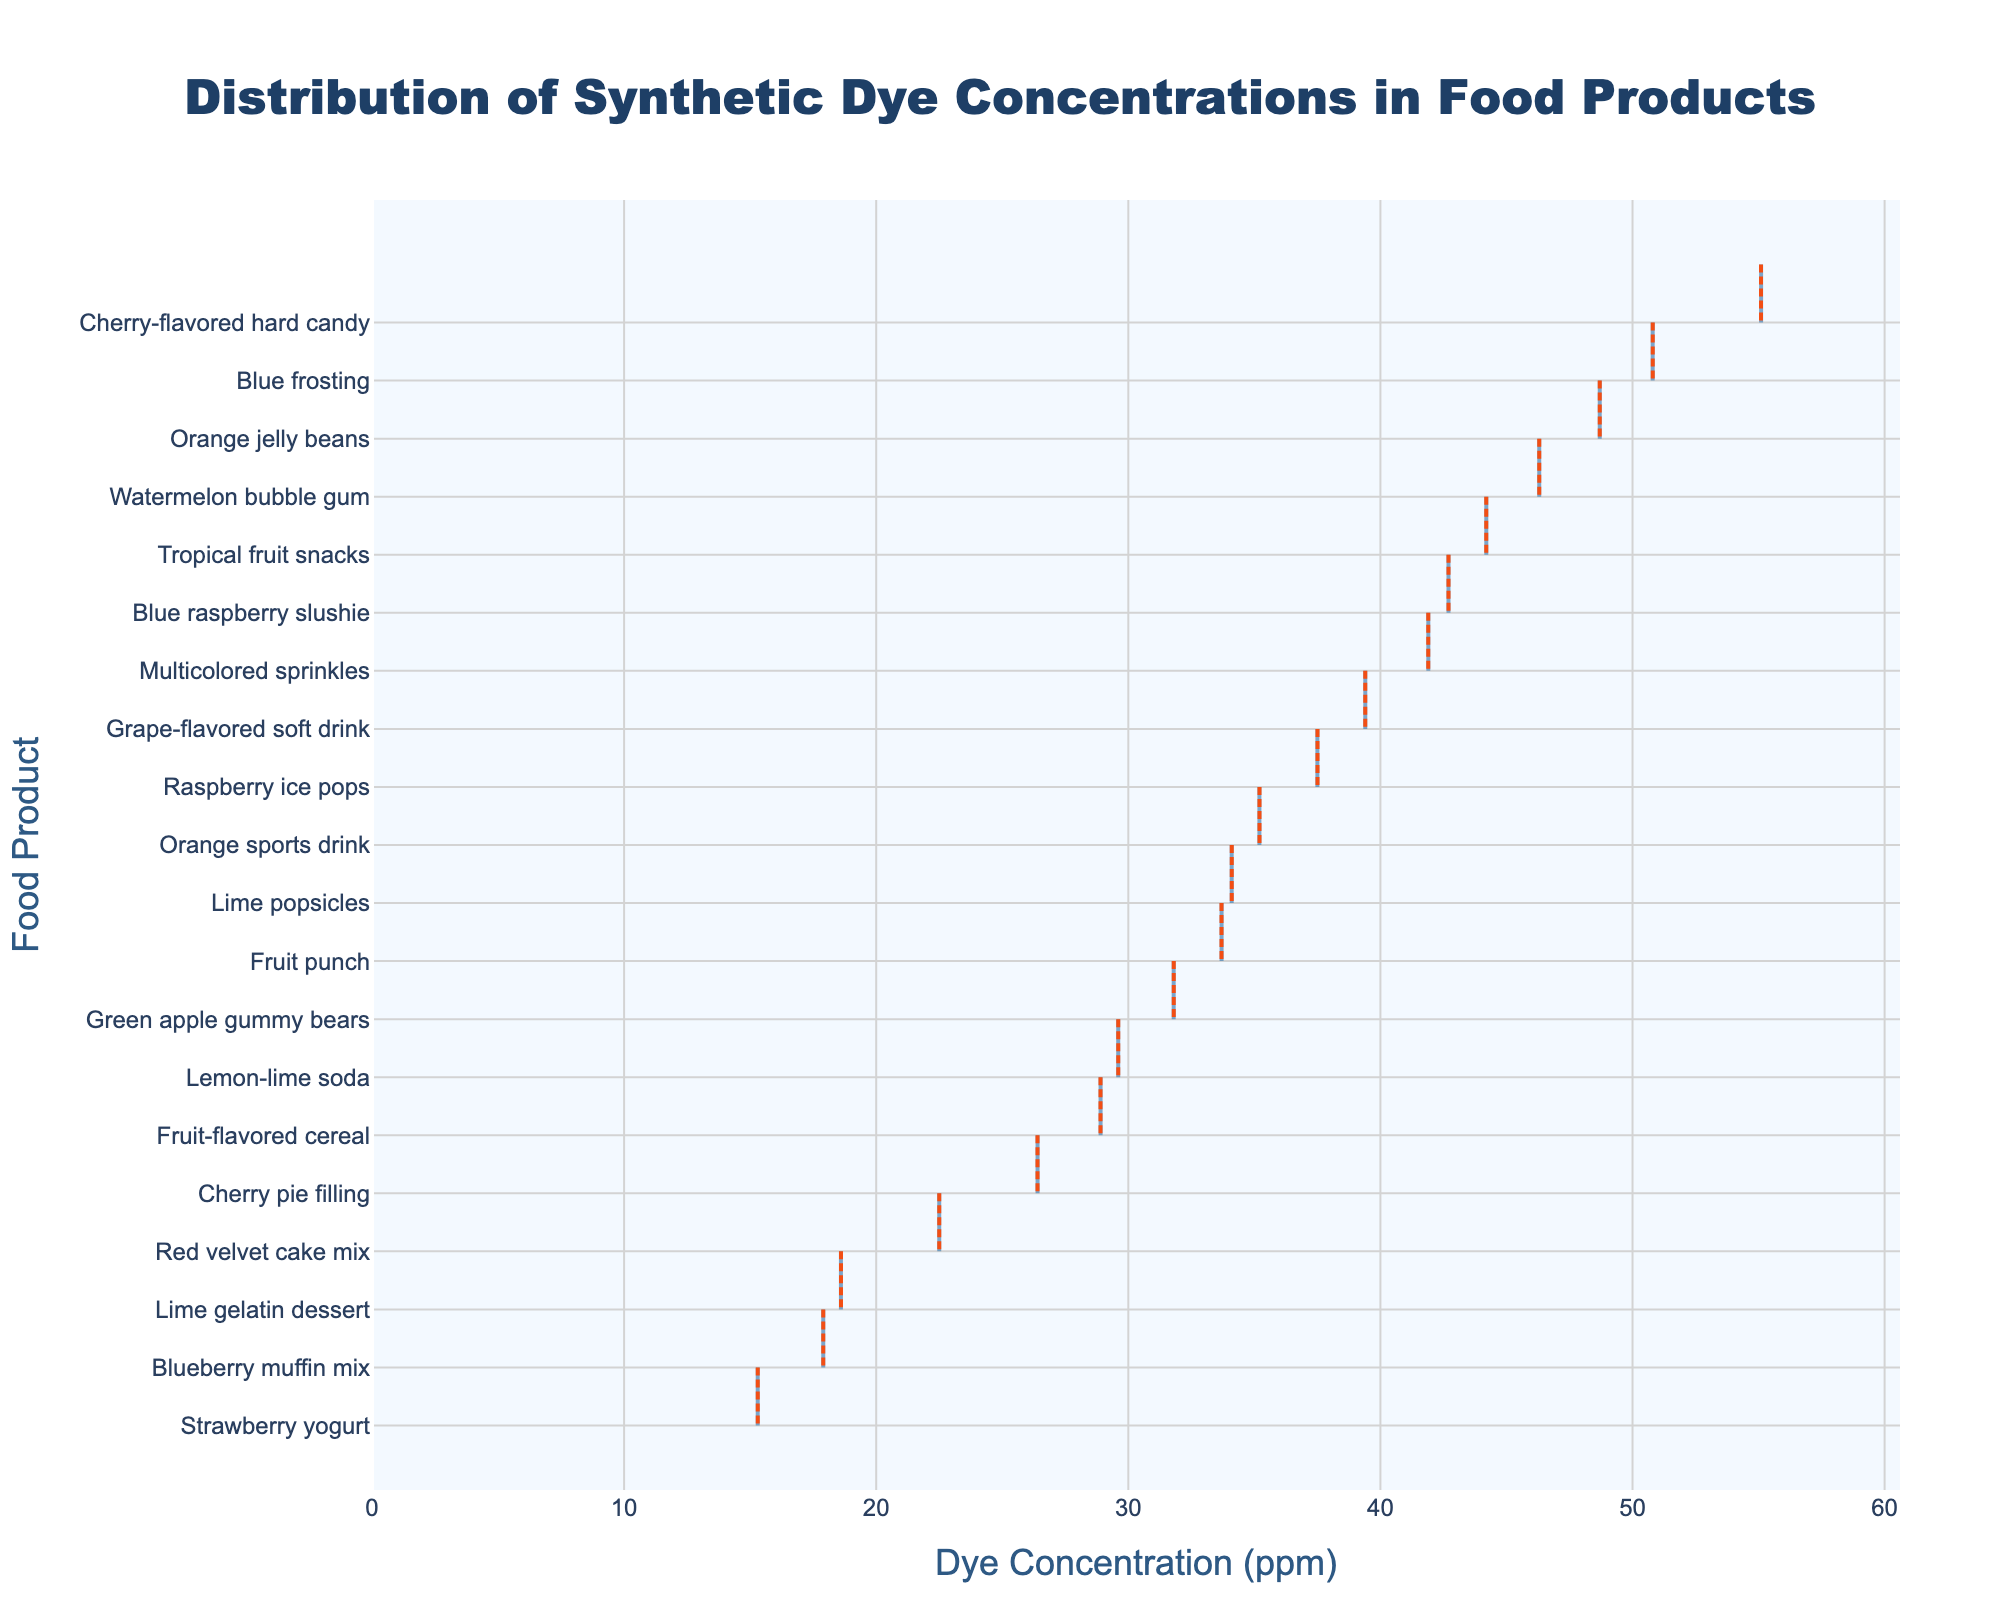what is the title of the figure? The title is usually displayed at the top of the chart. It provides a succinct description of the chart's purpose. The title "Distribution of Synthetic Dye Concentrations in Food Products" is clearly visible and centers the viewer's attention on the key aspect being visualized.
Answer: Distribution of Synthetic Dye Concentrations in Food Products How many food products are included in the density plot? To determine the number of food products in the plot, count the unique labels on the y-axis. Each label represents a distinct food product. There are 20 unique labels listed.
Answer: 20 What is the range of dye concentration (ppm) shown on the x-axis? The range can be determined by examining the x-axis values. The minimum shown is 0 ppm, and the maximum is slightly greater than the highest data point, extending to around 60 ppm.
Answer: 0 to 60 ppm Which food product has the highest concentration of synthetic dye? By identifying the food label associated with the densest part of the density plot on the higher end of the x-axis, we find that Cherry-flavored hard candy has the highest concentration around 55.1 ppm.
Answer: Cherry-flavored hard candy What can you infer about the general distribution of dye concentrations across the food products? Observing the density plot, one can see the distribution smears widely across the x-axis with concentrations mostly between 15 ppm and 50 ppm. The density peek hints most common concentrations clustering between 30 ppm to 40 ppm.
Answer: Most concentrations range from 15 ppm to 50 ppm What is the average dye concentration for the food products? Average can be calculated as the total of dye concentrations divided by the number of products. Sum of concentrations = 15.3 + 42.7 + 28.9 + 18.6 + 35.2 + 55.1 + 31.8 + 39.4 + 22.5 + 17.9 + 29.6 + 33.7 + 44.2 + 50.8 + 37.5 + 46.3 + 41.9 + 26.4 + 48.7 + 34.1 = 700.6 ppm. Number of products = 20. Therefore, average = 700.6 / 20.
Answer: 35.03 ppm Which two products have dye concentrations closest to the mean? First, calculate the mean dye concentration which is 35.03 ppm. Then find the products with concentrations closest to this value by comparing the differences. Blue raspberry slushie (42.7 ppm) and Orange sports drink (35.2 ppm) are closest to 35.03 ppm.
Answer: Blue raspberry slushie and Orange sports drink Is there any food product with a dye concentration exactly matching the average concentration? From the previously calculated mean of 35.03 ppm, none of the listed food products have a dye concentration that exactly matches this average.
Answer: No Which two food products have the most similar dye concentrations to each other? Compare the ppm values and find the pair with the smallest difference. Strawberry yogurt (15.3 ppm) and Blueberry muffin mix (17.9 ppm) have the smallest difference (2.6 ppm).
Answer: Strawberry yogurt and Blueberry muffin mix 